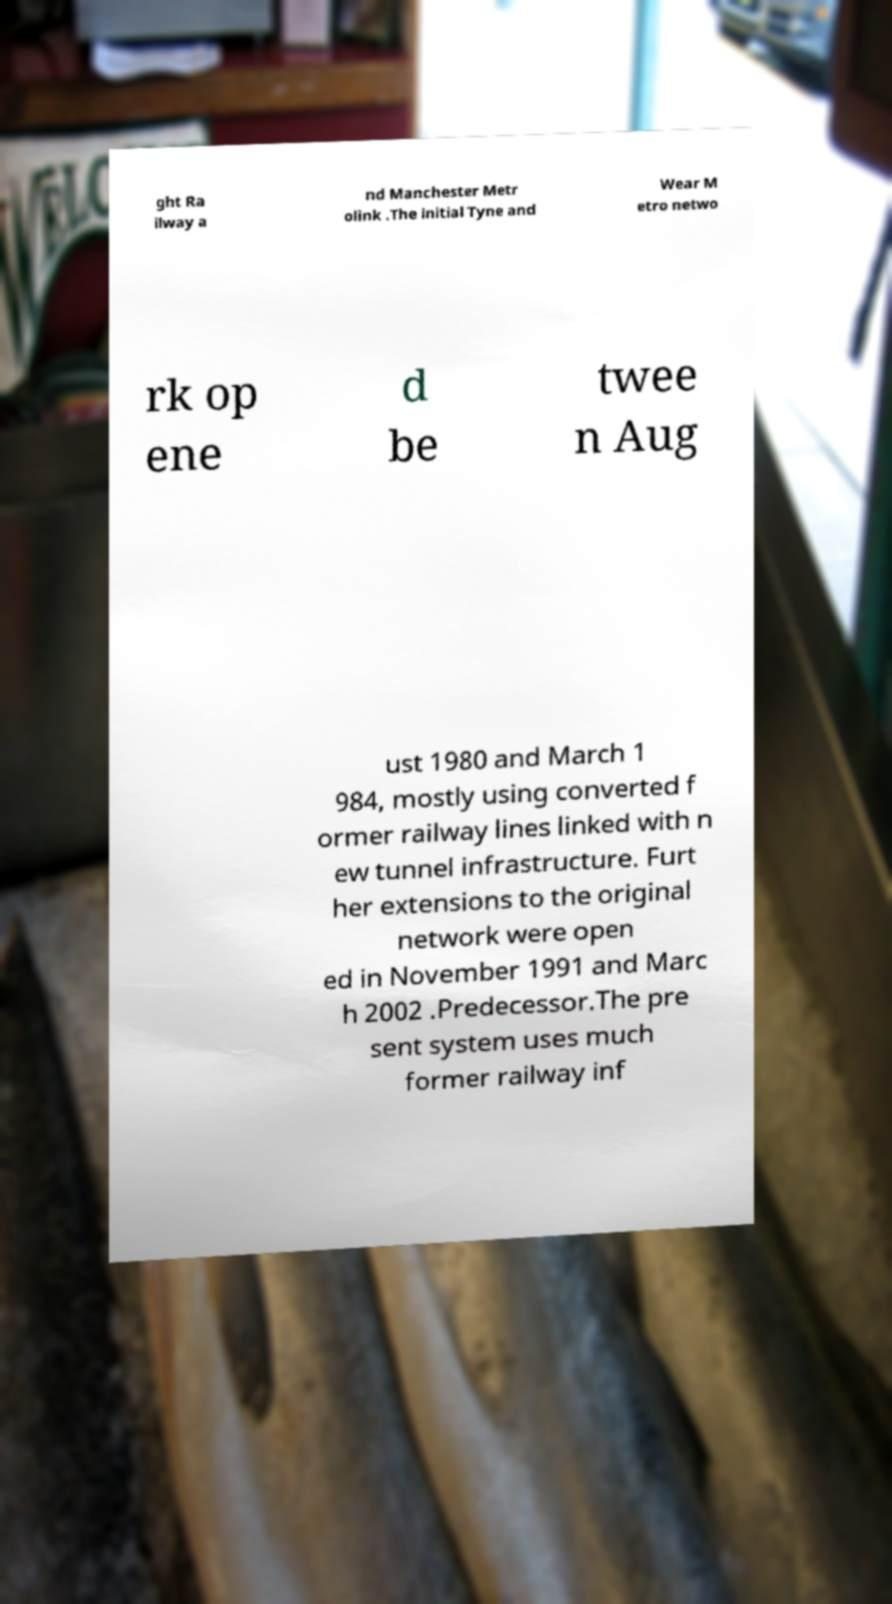Could you assist in decoding the text presented in this image and type it out clearly? ght Ra ilway a nd Manchester Metr olink .The initial Tyne and Wear M etro netwo rk op ene d be twee n Aug ust 1980 and March 1 984, mostly using converted f ormer railway lines linked with n ew tunnel infrastructure. Furt her extensions to the original network were open ed in November 1991 and Marc h 2002 .Predecessor.The pre sent system uses much former railway inf 